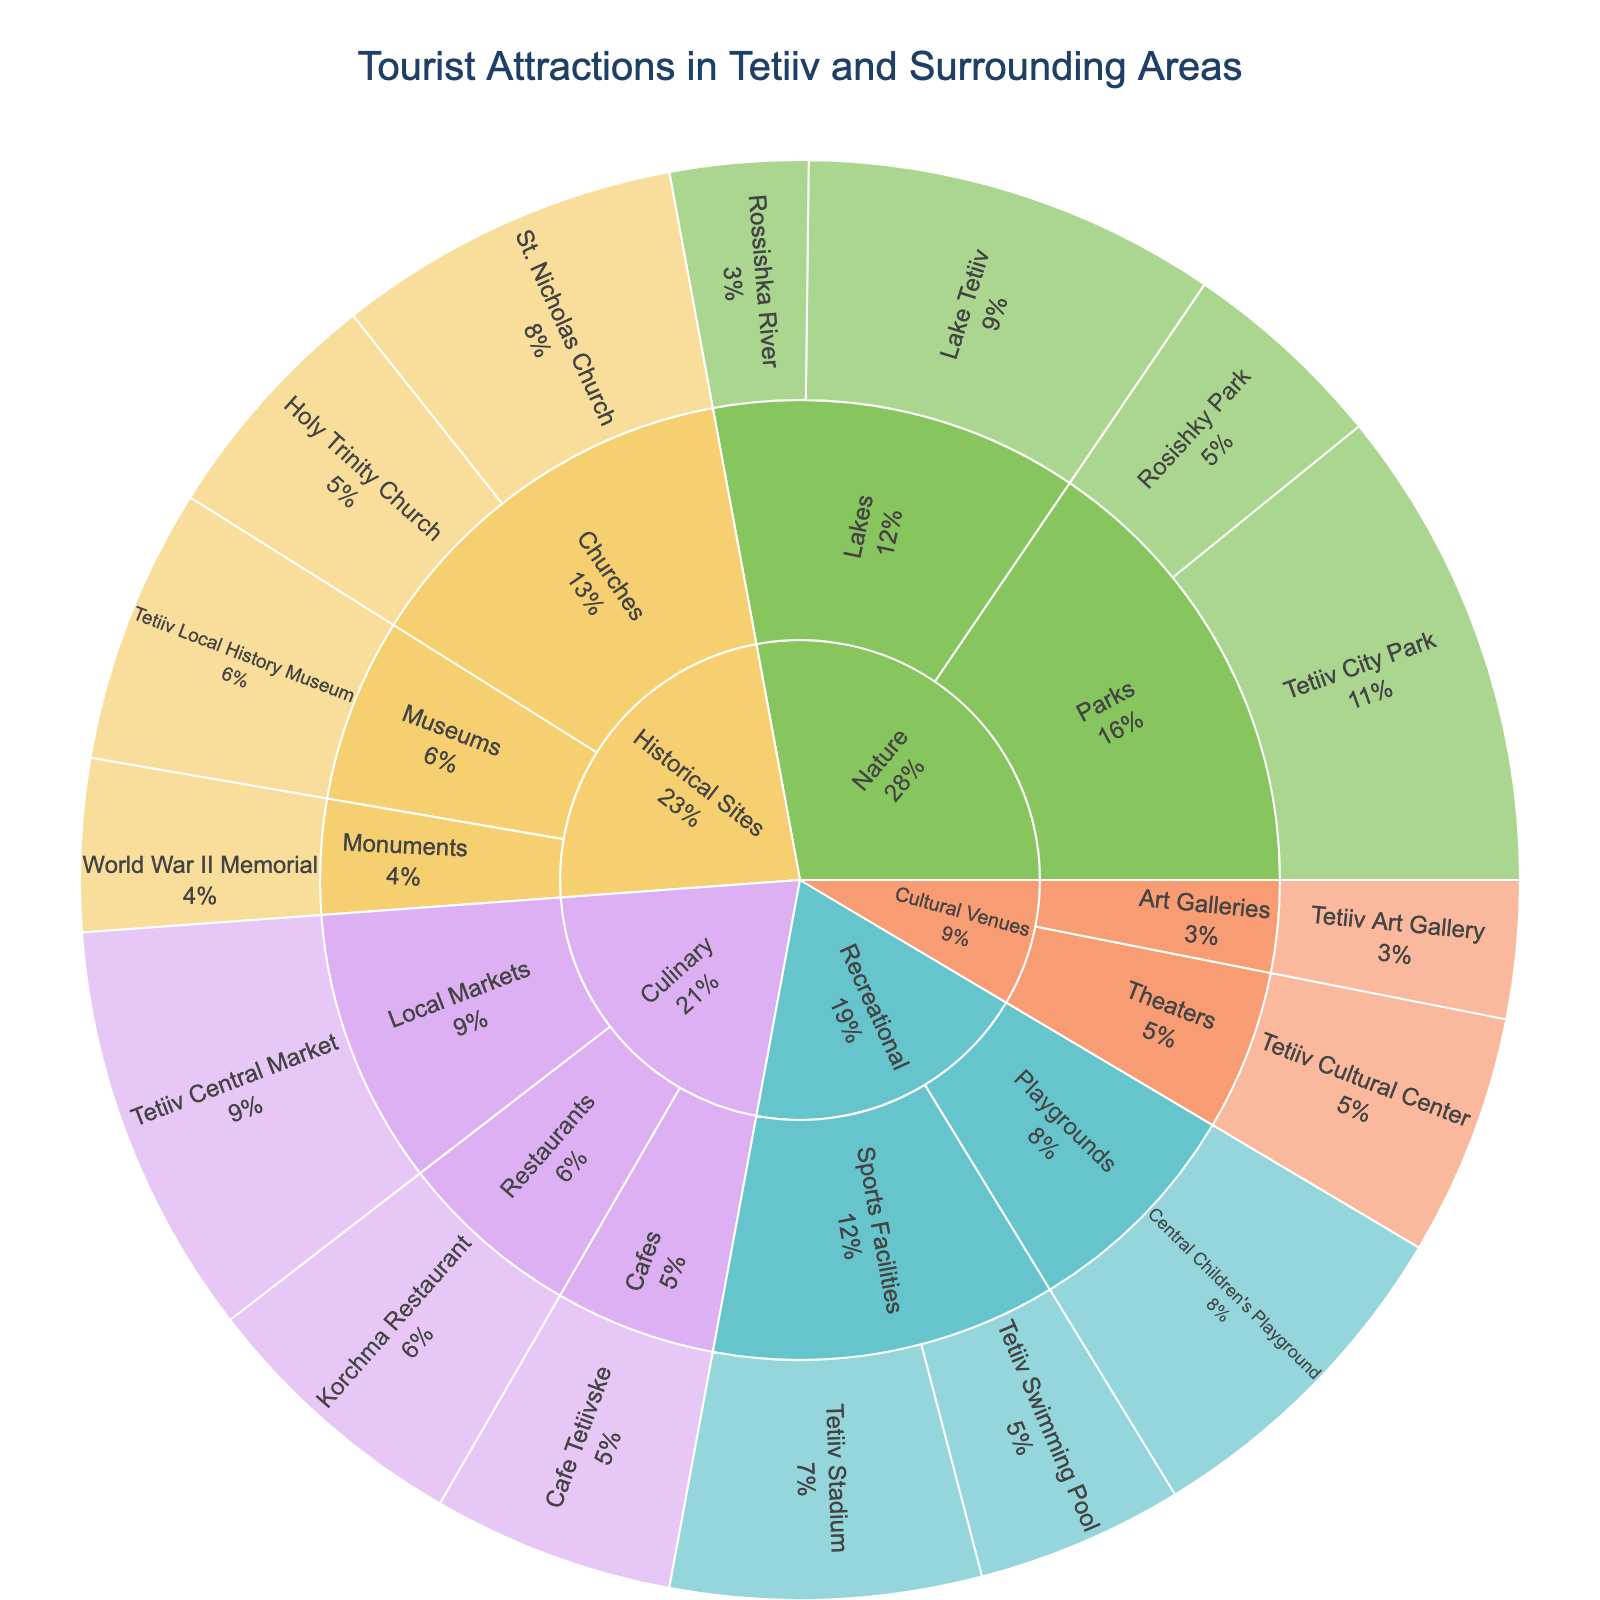What is the most visited tourist attraction in Tetiiv? By referring to the sunburst plot, we see that Tetiiv City Park has the highest number of visitors. It falls under the 'Nature' category and 'Parks' subcategory, with a total of 7,000 visitors.
Answer: Tetiiv City Park How many visitors does the Tetiiv Local History Museum get? Upon checking the sunburst plot, the Tetiiv Local History Museum, which is under the 'Historical Sites' category and the 'Museums' subcategory, has 4,000 visitors.
Answer: 4,000 Which category has the highest total number of visitors? To find this, we sum up the visitors in each category from the sunburst plot. Nature (Tetiiv City Park: 7,000; Rosishky Park: 3,000; Lake Tetiiv: 6,000; Rossishka River: 2,000) = 18,000; Recreational (Tetiiv Stadium: 4,500; Tetiiv Swimming Pool: 3,000; Central Children's Playground: 5,000) = 12,500; Culinary = 13,500; Historical Sites = 15,000; Cultural Venues = 5,500. Nature has the highest total of 18,000 visitors.
Answer: Nature Between St. Nicholas Church and Holy Trinity Church, which has more visitors? By referring to the sunburst plot, St. Nicholas Church has 5,000 visitors while Holy Trinity Church has 3,500 visitors. Thus, St. Nicholas Church has more visitors.
Answer: St. Nicholas Church What is the average number of visitors to attractions under the 'Culinary' category? The attractions under 'Culinary' are Korchma Restaurant (4,000), Cafe Tetiivske (3,500), and Tetiiv Central Market (6,000). Summing these gives 4,000 + 3,500 + 6,000 = 13,500. Dividing by 3, the average is 13,500 / 3 = 4,500 visitors.
Answer: 4,500 Is there any attraction in the 'Cultural Venues' category that has more than 4,000 visitors? By inspecting the sunburst plot, the attractions under 'Cultural Venues' are Tetiiv Cultural Center with 3,500 visitors and Tetiiv Art Gallery with 2,000 visitors, both of which have fewer than 4,000 visitors.
Answer: No How many visitors are there to the Tetiiv Central Market compared to Lake Tetiiv? From the sunburst plot, Tetiiv Central Market has 6,000 visitors and Lake Tetiiv also has 6,000 visitors. Hence, both attractions have an equal number of visitors.
Answer: Equal What subcategory of 'Nature' attracts the highest number of visitors? Observing the sunburst plot, among the 'Nature' subcategories, Parks (Tetiiv City Park: 7,000; Rosishky Park: 3,000) has a total of 10,000 visitors, which is higher than Lakes (Lake Tetiiv: 6,000; Rossishka River: 2,000) with a total of 8,000 visitors.
Answer: Parks How many visitors do all historical site attractions combined have? Adding the visitors from the 'Historical Sites' category, we get St. Nicholas Church (5,000), Holy Trinity Church (3,500), Tetiiv Local History Museum (4,000), and World War II Memorial (2,500). The total is 5,000 + 3,500 + 4,000 + 2,500 = 15,000 visitors.
Answer: 15,000 